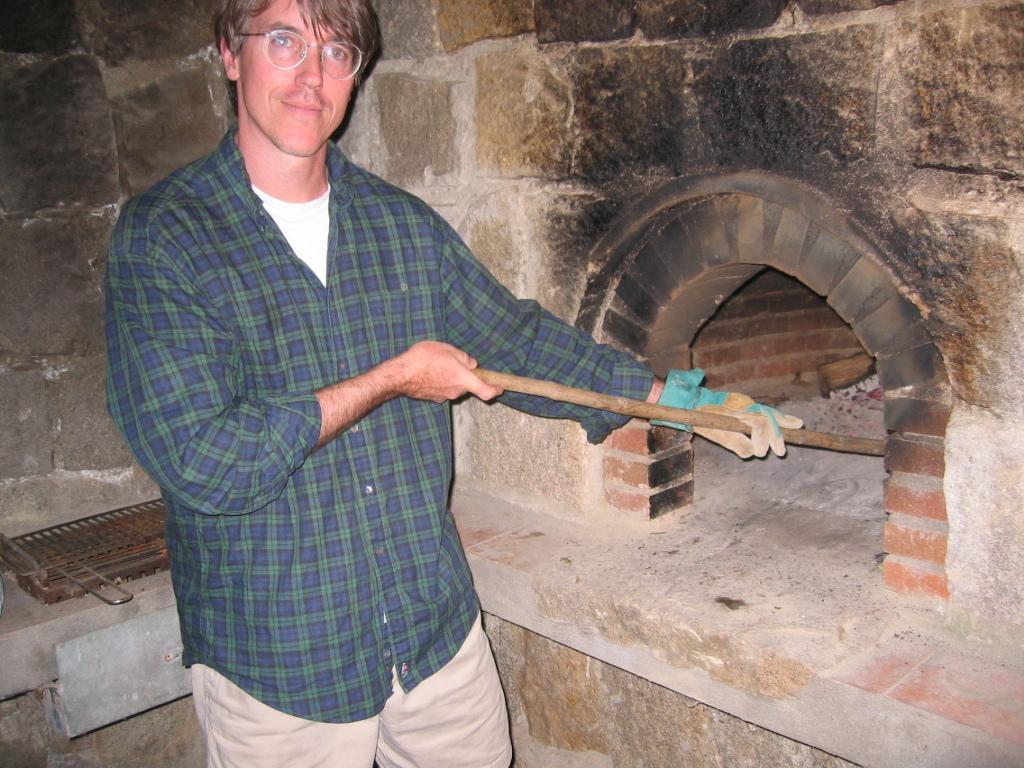Describe this image in one or two sentences. In this image there is one person standing and holding a stick on the left side of this image and there is a wall in the background. There is one object kept on the left side of this image. 